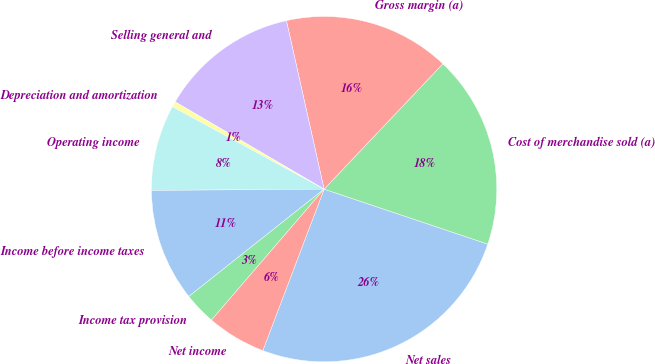<chart> <loc_0><loc_0><loc_500><loc_500><pie_chart><fcel>Net sales<fcel>Cost of merchandise sold (a)<fcel>Gross margin (a)<fcel>Selling general and<fcel>Depreciation and amortization<fcel>Operating income<fcel>Income before income taxes<fcel>Income tax provision<fcel>Net income<nl><fcel>25.61%<fcel>18.08%<fcel>15.57%<fcel>13.06%<fcel>0.51%<fcel>8.04%<fcel>10.55%<fcel>3.02%<fcel>5.53%<nl></chart> 